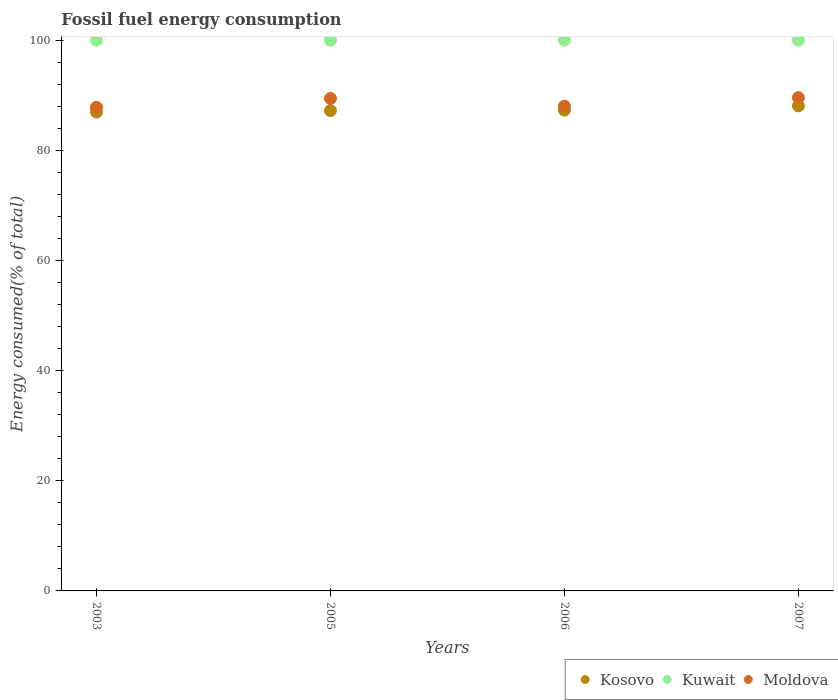Is the number of dotlines equal to the number of legend labels?
Make the answer very short. Yes. What is the percentage of energy consumed in Moldova in 2005?
Your response must be concise. 89.42. Across all years, what is the minimum percentage of energy consumed in Moldova?
Your answer should be very brief. 87.8. In which year was the percentage of energy consumed in Kosovo maximum?
Your response must be concise. 2007. What is the total percentage of energy consumed in Kosovo in the graph?
Ensure brevity in your answer.  349.53. What is the difference between the percentage of energy consumed in Kosovo in 2005 and that in 2006?
Offer a terse response. -0.09. What is the difference between the percentage of energy consumed in Kosovo in 2006 and the percentage of energy consumed in Moldova in 2007?
Your response must be concise. -2.26. What is the average percentage of energy consumed in Kosovo per year?
Your answer should be compact. 87.38. In the year 2003, what is the difference between the percentage of energy consumed in Kosovo and percentage of energy consumed in Moldova?
Give a very brief answer. -0.85. In how many years, is the percentage of energy consumed in Kosovo greater than 48 %?
Give a very brief answer. 4. What is the ratio of the percentage of energy consumed in Kuwait in 2006 to that in 2007?
Give a very brief answer. 1. Is the percentage of energy consumed in Moldova in 2003 less than that in 2005?
Provide a short and direct response. Yes. Is the difference between the percentage of energy consumed in Kosovo in 2003 and 2005 greater than the difference between the percentage of energy consumed in Moldova in 2003 and 2005?
Your answer should be very brief. Yes. What is the difference between the highest and the second highest percentage of energy consumed in Kosovo?
Your response must be concise. 0.77. What is the difference between the highest and the lowest percentage of energy consumed in Kosovo?
Ensure brevity in your answer.  1.12. In how many years, is the percentage of energy consumed in Kosovo greater than the average percentage of energy consumed in Kosovo taken over all years?
Make the answer very short. 1. Is the sum of the percentage of energy consumed in Kuwait in 2005 and 2006 greater than the maximum percentage of energy consumed in Kosovo across all years?
Offer a terse response. Yes. Does the percentage of energy consumed in Kuwait monotonically increase over the years?
Give a very brief answer. No. Is the percentage of energy consumed in Kosovo strictly greater than the percentage of energy consumed in Kuwait over the years?
Your response must be concise. No. Is the percentage of energy consumed in Moldova strictly less than the percentage of energy consumed in Kuwait over the years?
Keep it short and to the point. Yes. How many dotlines are there?
Offer a terse response. 3. How many years are there in the graph?
Provide a short and direct response. 4. Does the graph contain any zero values?
Ensure brevity in your answer.  No. What is the title of the graph?
Keep it short and to the point. Fossil fuel energy consumption. What is the label or title of the Y-axis?
Your answer should be very brief. Energy consumed(% of total). What is the Energy consumed(% of total) in Kosovo in 2003?
Your answer should be compact. 86.95. What is the Energy consumed(% of total) in Kuwait in 2003?
Provide a short and direct response. 100. What is the Energy consumed(% of total) of Moldova in 2003?
Provide a short and direct response. 87.8. What is the Energy consumed(% of total) in Kosovo in 2005?
Offer a terse response. 87.21. What is the Energy consumed(% of total) of Moldova in 2005?
Keep it short and to the point. 89.42. What is the Energy consumed(% of total) in Kosovo in 2006?
Provide a short and direct response. 87.3. What is the Energy consumed(% of total) of Kuwait in 2006?
Provide a succinct answer. 100. What is the Energy consumed(% of total) in Moldova in 2006?
Give a very brief answer. 88.01. What is the Energy consumed(% of total) of Kosovo in 2007?
Your answer should be compact. 88.07. What is the Energy consumed(% of total) in Kuwait in 2007?
Your response must be concise. 100. What is the Energy consumed(% of total) of Moldova in 2007?
Your answer should be compact. 89.56. Across all years, what is the maximum Energy consumed(% of total) in Kosovo?
Offer a terse response. 88.07. Across all years, what is the maximum Energy consumed(% of total) in Kuwait?
Give a very brief answer. 100. Across all years, what is the maximum Energy consumed(% of total) of Moldova?
Your response must be concise. 89.56. Across all years, what is the minimum Energy consumed(% of total) of Kosovo?
Offer a terse response. 86.95. Across all years, what is the minimum Energy consumed(% of total) in Kuwait?
Give a very brief answer. 100. Across all years, what is the minimum Energy consumed(% of total) of Moldova?
Your answer should be very brief. 87.8. What is the total Energy consumed(% of total) of Kosovo in the graph?
Make the answer very short. 349.53. What is the total Energy consumed(% of total) in Kuwait in the graph?
Your response must be concise. 400. What is the total Energy consumed(% of total) in Moldova in the graph?
Give a very brief answer. 354.79. What is the difference between the Energy consumed(% of total) of Kosovo in 2003 and that in 2005?
Make the answer very short. -0.26. What is the difference between the Energy consumed(% of total) in Kuwait in 2003 and that in 2005?
Your answer should be very brief. -0. What is the difference between the Energy consumed(% of total) of Moldova in 2003 and that in 2005?
Offer a terse response. -1.62. What is the difference between the Energy consumed(% of total) in Kosovo in 2003 and that in 2006?
Your answer should be very brief. -0.35. What is the difference between the Energy consumed(% of total) of Kuwait in 2003 and that in 2006?
Make the answer very short. -0. What is the difference between the Energy consumed(% of total) of Moldova in 2003 and that in 2006?
Your answer should be compact. -0.2. What is the difference between the Energy consumed(% of total) in Kosovo in 2003 and that in 2007?
Provide a succinct answer. -1.12. What is the difference between the Energy consumed(% of total) in Kuwait in 2003 and that in 2007?
Keep it short and to the point. -0. What is the difference between the Energy consumed(% of total) in Moldova in 2003 and that in 2007?
Your answer should be compact. -1.75. What is the difference between the Energy consumed(% of total) of Kosovo in 2005 and that in 2006?
Your answer should be very brief. -0.09. What is the difference between the Energy consumed(% of total) in Moldova in 2005 and that in 2006?
Offer a very short reply. 1.41. What is the difference between the Energy consumed(% of total) in Kosovo in 2005 and that in 2007?
Your answer should be compact. -0.87. What is the difference between the Energy consumed(% of total) of Kuwait in 2005 and that in 2007?
Ensure brevity in your answer.  0. What is the difference between the Energy consumed(% of total) of Moldova in 2005 and that in 2007?
Provide a short and direct response. -0.13. What is the difference between the Energy consumed(% of total) in Kosovo in 2006 and that in 2007?
Keep it short and to the point. -0.77. What is the difference between the Energy consumed(% of total) in Moldova in 2006 and that in 2007?
Your answer should be compact. -1.55. What is the difference between the Energy consumed(% of total) in Kosovo in 2003 and the Energy consumed(% of total) in Kuwait in 2005?
Offer a very short reply. -13.05. What is the difference between the Energy consumed(% of total) of Kosovo in 2003 and the Energy consumed(% of total) of Moldova in 2005?
Your response must be concise. -2.47. What is the difference between the Energy consumed(% of total) of Kuwait in 2003 and the Energy consumed(% of total) of Moldova in 2005?
Provide a short and direct response. 10.58. What is the difference between the Energy consumed(% of total) of Kosovo in 2003 and the Energy consumed(% of total) of Kuwait in 2006?
Your answer should be very brief. -13.05. What is the difference between the Energy consumed(% of total) of Kosovo in 2003 and the Energy consumed(% of total) of Moldova in 2006?
Keep it short and to the point. -1.06. What is the difference between the Energy consumed(% of total) in Kuwait in 2003 and the Energy consumed(% of total) in Moldova in 2006?
Offer a very short reply. 11.99. What is the difference between the Energy consumed(% of total) of Kosovo in 2003 and the Energy consumed(% of total) of Kuwait in 2007?
Offer a very short reply. -13.05. What is the difference between the Energy consumed(% of total) in Kosovo in 2003 and the Energy consumed(% of total) in Moldova in 2007?
Provide a short and direct response. -2.6. What is the difference between the Energy consumed(% of total) of Kuwait in 2003 and the Energy consumed(% of total) of Moldova in 2007?
Offer a terse response. 10.44. What is the difference between the Energy consumed(% of total) in Kosovo in 2005 and the Energy consumed(% of total) in Kuwait in 2006?
Your answer should be very brief. -12.79. What is the difference between the Energy consumed(% of total) of Kosovo in 2005 and the Energy consumed(% of total) of Moldova in 2006?
Provide a succinct answer. -0.8. What is the difference between the Energy consumed(% of total) of Kuwait in 2005 and the Energy consumed(% of total) of Moldova in 2006?
Make the answer very short. 11.99. What is the difference between the Energy consumed(% of total) in Kosovo in 2005 and the Energy consumed(% of total) in Kuwait in 2007?
Offer a very short reply. -12.79. What is the difference between the Energy consumed(% of total) of Kosovo in 2005 and the Energy consumed(% of total) of Moldova in 2007?
Provide a succinct answer. -2.35. What is the difference between the Energy consumed(% of total) of Kuwait in 2005 and the Energy consumed(% of total) of Moldova in 2007?
Your answer should be very brief. 10.44. What is the difference between the Energy consumed(% of total) in Kosovo in 2006 and the Energy consumed(% of total) in Kuwait in 2007?
Offer a terse response. -12.7. What is the difference between the Energy consumed(% of total) in Kosovo in 2006 and the Energy consumed(% of total) in Moldova in 2007?
Your answer should be compact. -2.26. What is the difference between the Energy consumed(% of total) in Kuwait in 2006 and the Energy consumed(% of total) in Moldova in 2007?
Keep it short and to the point. 10.44. What is the average Energy consumed(% of total) in Kosovo per year?
Keep it short and to the point. 87.38. What is the average Energy consumed(% of total) in Kuwait per year?
Offer a very short reply. 100. What is the average Energy consumed(% of total) of Moldova per year?
Provide a succinct answer. 88.7. In the year 2003, what is the difference between the Energy consumed(% of total) of Kosovo and Energy consumed(% of total) of Kuwait?
Ensure brevity in your answer.  -13.05. In the year 2003, what is the difference between the Energy consumed(% of total) of Kosovo and Energy consumed(% of total) of Moldova?
Offer a very short reply. -0.85. In the year 2003, what is the difference between the Energy consumed(% of total) of Kuwait and Energy consumed(% of total) of Moldova?
Your answer should be compact. 12.2. In the year 2005, what is the difference between the Energy consumed(% of total) of Kosovo and Energy consumed(% of total) of Kuwait?
Ensure brevity in your answer.  -12.79. In the year 2005, what is the difference between the Energy consumed(% of total) of Kosovo and Energy consumed(% of total) of Moldova?
Your answer should be very brief. -2.21. In the year 2005, what is the difference between the Energy consumed(% of total) of Kuwait and Energy consumed(% of total) of Moldova?
Provide a short and direct response. 10.58. In the year 2006, what is the difference between the Energy consumed(% of total) of Kosovo and Energy consumed(% of total) of Kuwait?
Provide a succinct answer. -12.7. In the year 2006, what is the difference between the Energy consumed(% of total) in Kosovo and Energy consumed(% of total) in Moldova?
Your answer should be very brief. -0.71. In the year 2006, what is the difference between the Energy consumed(% of total) of Kuwait and Energy consumed(% of total) of Moldova?
Keep it short and to the point. 11.99. In the year 2007, what is the difference between the Energy consumed(% of total) of Kosovo and Energy consumed(% of total) of Kuwait?
Make the answer very short. -11.93. In the year 2007, what is the difference between the Energy consumed(% of total) in Kosovo and Energy consumed(% of total) in Moldova?
Give a very brief answer. -1.48. In the year 2007, what is the difference between the Energy consumed(% of total) of Kuwait and Energy consumed(% of total) of Moldova?
Keep it short and to the point. 10.44. What is the ratio of the Energy consumed(% of total) in Kosovo in 2003 to that in 2005?
Keep it short and to the point. 1. What is the ratio of the Energy consumed(% of total) in Kuwait in 2003 to that in 2005?
Offer a very short reply. 1. What is the ratio of the Energy consumed(% of total) of Moldova in 2003 to that in 2005?
Your response must be concise. 0.98. What is the ratio of the Energy consumed(% of total) in Kosovo in 2003 to that in 2006?
Your answer should be compact. 1. What is the ratio of the Energy consumed(% of total) in Kuwait in 2003 to that in 2006?
Offer a terse response. 1. What is the ratio of the Energy consumed(% of total) of Moldova in 2003 to that in 2006?
Your response must be concise. 1. What is the ratio of the Energy consumed(% of total) of Kosovo in 2003 to that in 2007?
Offer a terse response. 0.99. What is the ratio of the Energy consumed(% of total) of Moldova in 2003 to that in 2007?
Offer a terse response. 0.98. What is the ratio of the Energy consumed(% of total) of Kuwait in 2005 to that in 2006?
Keep it short and to the point. 1. What is the ratio of the Energy consumed(% of total) in Kosovo in 2005 to that in 2007?
Your response must be concise. 0.99. What is the ratio of the Energy consumed(% of total) of Kuwait in 2005 to that in 2007?
Make the answer very short. 1. What is the ratio of the Energy consumed(% of total) in Moldova in 2005 to that in 2007?
Offer a terse response. 1. What is the ratio of the Energy consumed(% of total) of Kuwait in 2006 to that in 2007?
Ensure brevity in your answer.  1. What is the ratio of the Energy consumed(% of total) in Moldova in 2006 to that in 2007?
Offer a terse response. 0.98. What is the difference between the highest and the second highest Energy consumed(% of total) of Kosovo?
Your response must be concise. 0.77. What is the difference between the highest and the second highest Energy consumed(% of total) of Kuwait?
Keep it short and to the point. 0. What is the difference between the highest and the second highest Energy consumed(% of total) of Moldova?
Keep it short and to the point. 0.13. What is the difference between the highest and the lowest Energy consumed(% of total) of Kosovo?
Provide a short and direct response. 1.12. What is the difference between the highest and the lowest Energy consumed(% of total) in Kuwait?
Your answer should be very brief. 0. What is the difference between the highest and the lowest Energy consumed(% of total) of Moldova?
Keep it short and to the point. 1.75. 